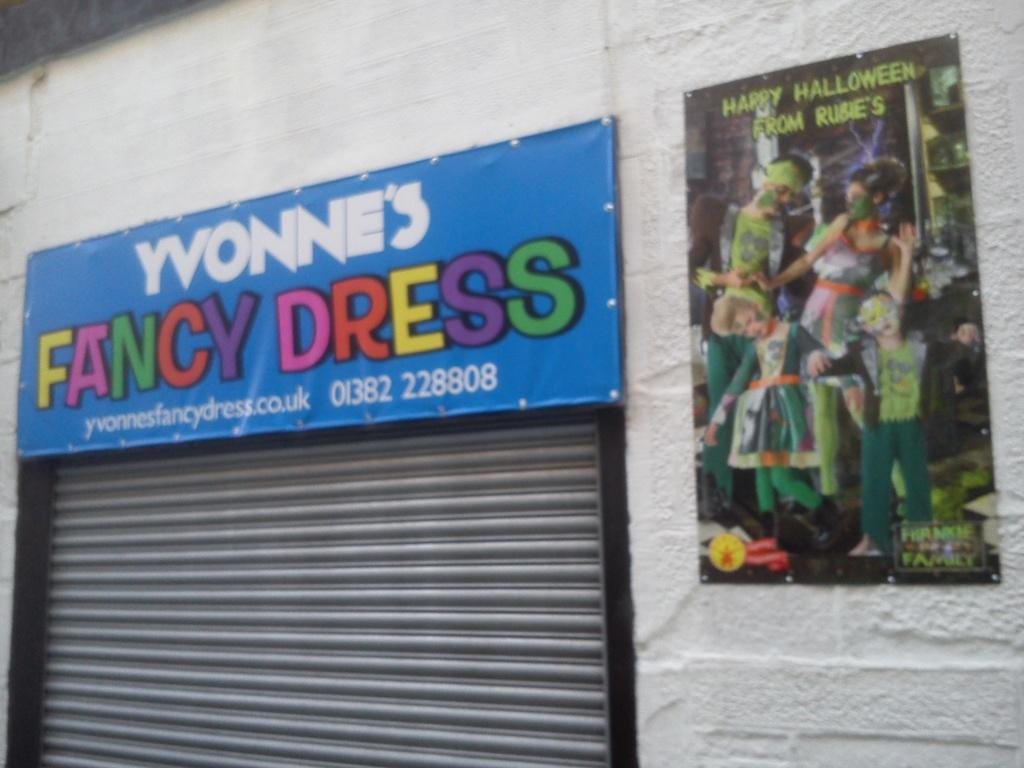What type of structure is visible in the image? There is a building in the image. What feature can be seen on the building? There is a rolling shutter in the image. What are the two banners in the image used for? The banners are used to display information or advertisements, as there is writing on them. Can you describe the people present in the image? There are people present in the image, but their specific actions or appearances are not mentioned in the provided facts. Can you tell me how deep the ocean is in the image? There is no ocean present in the image; it features a building with a rolling shutter and two banners. 